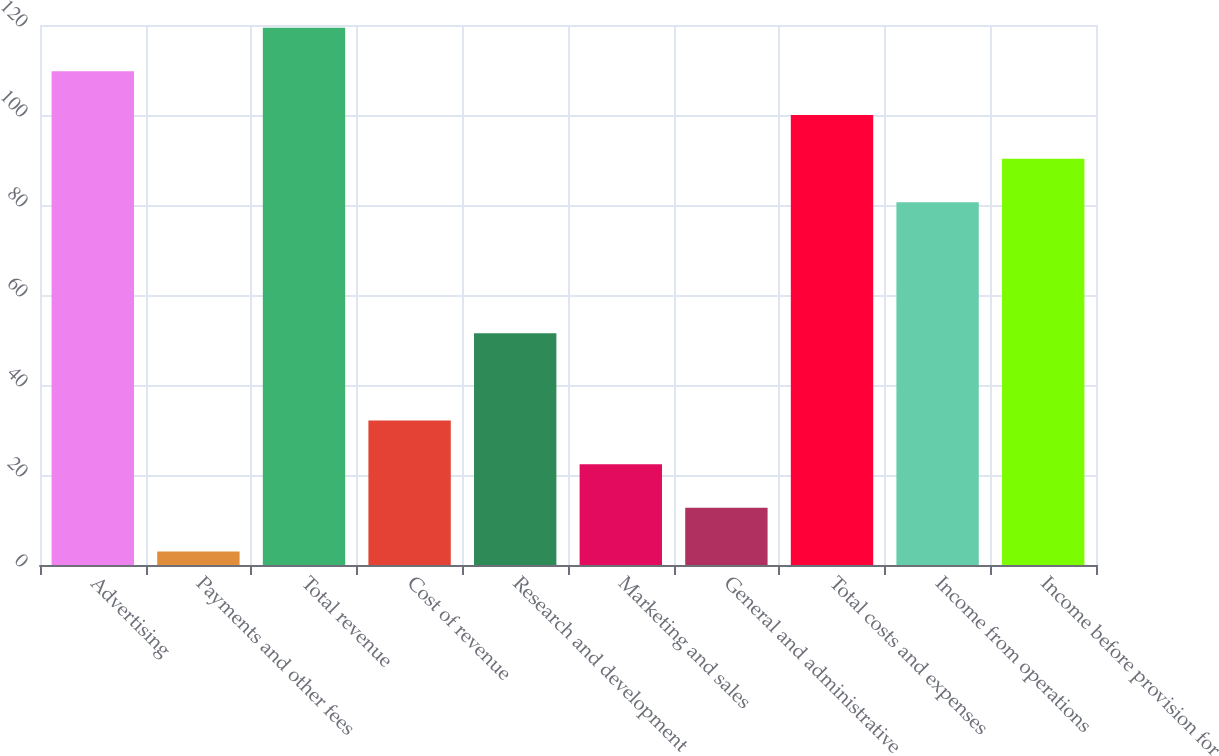<chart> <loc_0><loc_0><loc_500><loc_500><bar_chart><fcel>Advertising<fcel>Payments and other fees<fcel>Total revenue<fcel>Cost of revenue<fcel>Research and development<fcel>Marketing and sales<fcel>General and administrative<fcel>Total costs and expenses<fcel>Income from operations<fcel>Income before provision for<nl><fcel>109.7<fcel>3<fcel>119.4<fcel>32.1<fcel>51.5<fcel>22.4<fcel>12.7<fcel>100<fcel>80.6<fcel>90.3<nl></chart> 